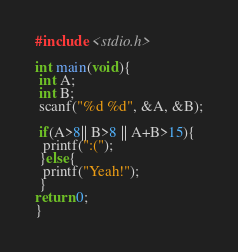Convert code to text. <code><loc_0><loc_0><loc_500><loc_500><_C_>#include <stdio.h>

int main(void){
 int A;
 int B;
 scanf("%d %d", &A, &B);

 if(A>8|| B>8 || A+B>15){
  printf(":(");
 }else{
  printf("Yeah!");
 }
return 0;
}</code> 